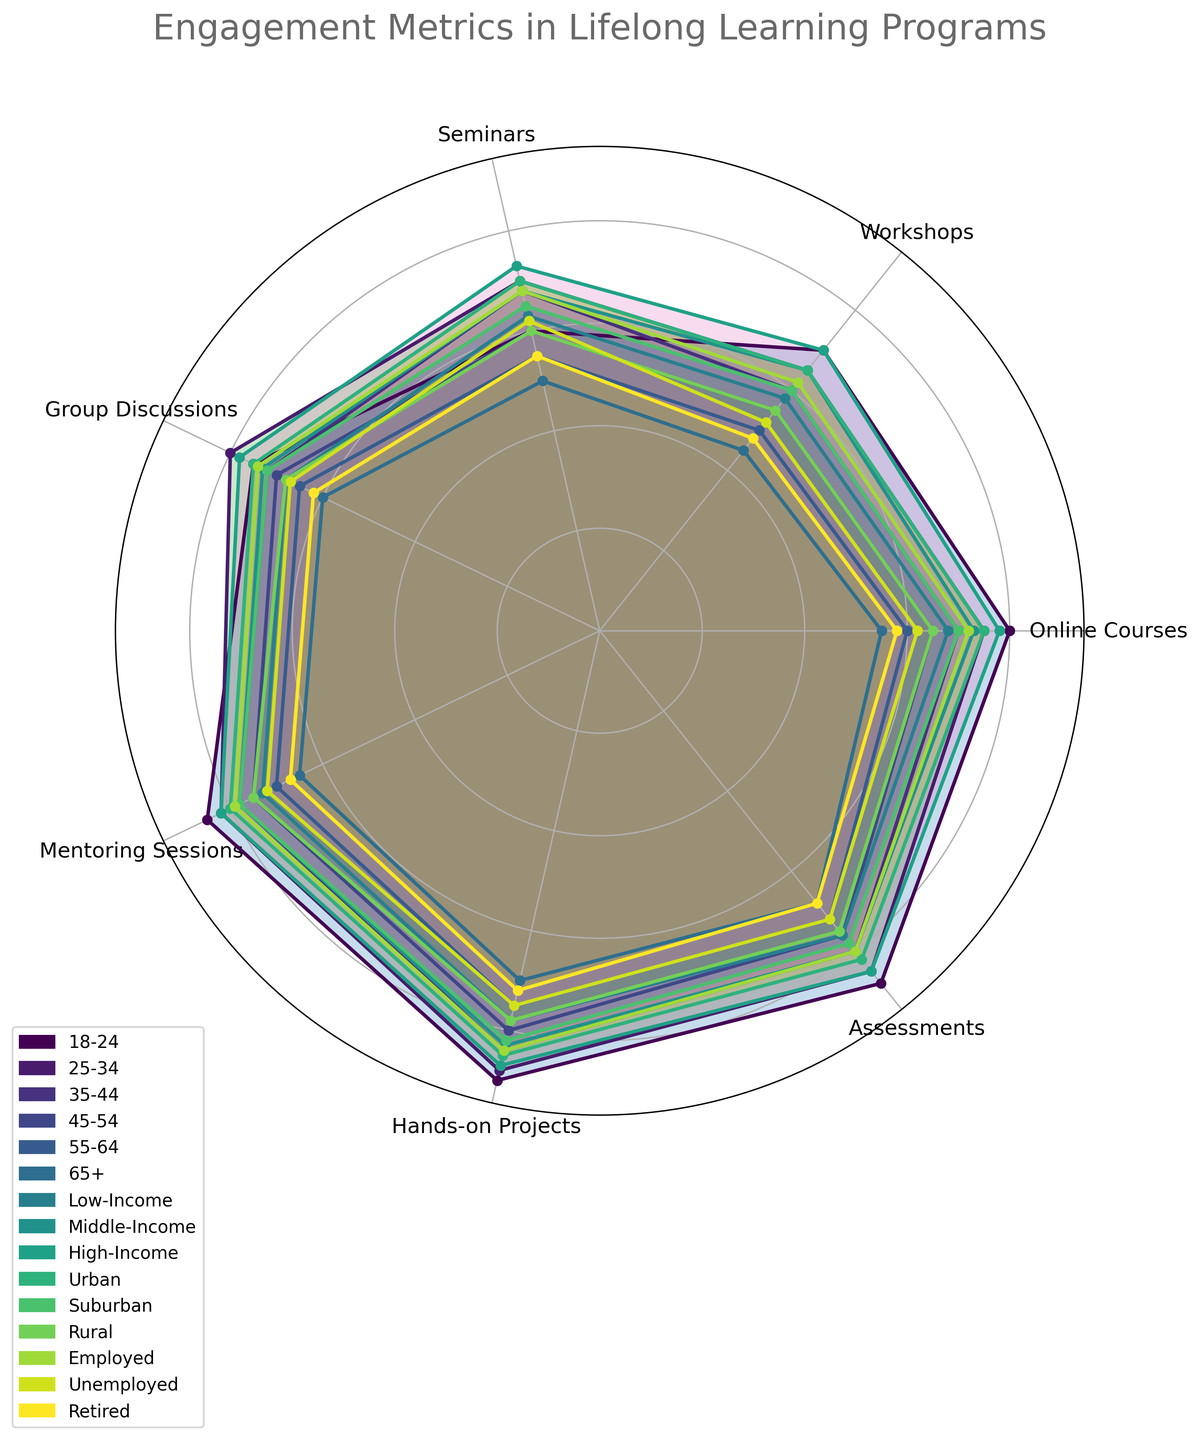What's the highest engagement metric for the 18-24 demographic? In the radar chart, locate the 18-24 demographic line and observe the metric that reaches the highest point. The highest metric for the 18-24 demographic is 90 for Hands-on Projects.
Answer: Hands-on Projects Which demographic has the lowest engagement in Online Courses? Trace the Online Courses axis on the radar chart and identify which demographic has the lowest point on this axis. The lowest engagement in Online Courses is for Retired individuals, with a score of 58.
Answer: Retired Compare the engagement in Workshops between the Low-Income and High-Income demographics. Which one is higher? On the radar chart, locate the lines for Low-Income and High-Income demographics and examine the points on the Workshops axis. The High-Income demographic has a higher engagement in Workshops with a score of 70 compared to 58 for Low-Income.
Answer: High-Income What is the average engagement score for the 45-54 demographic across all metrics? Sum the engagement scores for all metrics in the 45-54 demographic and divide by the number of metrics (7). The sum is 65 + 55 + 60 + 70 + 75 + 80 + 76 = 481. The average is 481 / 7 = 68.71.
Answer: 68.71 Which demographic has a higher average engagement, Suburban or Rural? Calculate the average engagement for both Suburban and Rural demographics. For Suburban, the sum is 70 + 60 + 65 + 72 + 78 + 82 + 78 = 505, and the average is 505 / 7 = 72.14. For Rural, the sum is 65 + 55 + 60 + 68 + 75 + 78 + 75 = 476, and the average is 476 / 7 = 68. Therefore, Suburban has a higher average engagement.
Answer: Suburban Compare the engagement in Group Discussions between the Urban and Employed demographics. Which demographic shows higher engagement? Examine the radar chart and compare the points for Urban and Employed demographics on the Group Discussions axis. Both Urban and Employed have the same engagement score in Group Discussions, which is 75.
Answer: Equal What's the median engagement score for the 35-44 demographic? List the scores for the 35-44 demographic: 70, 60, 68, 72, 78, 84, 80. The median is the middle value when ordered: 60, 68, 70, 72, 78, 80, 84. The median value is 72.
Answer: 72 How does the engagement in Hands-on Projects differ between the 18-24 and 65+ demographics? Locate the points for Hands-on Projects for the 18-24 and 65+ demographics on the radar chart. The score for 18-24 is 90, and for 65+ is 70. The difference is 90 - 70 = 20.
Answer: 20 What is the range of engagement in Assessments for all demographics? Find the highest and lowest engagement scores for Assessments across all demographics. The highest score is 88 (18-24 demographic) and the lowest is 68 (65+ and Retired demographics). The range is 88 - 68 = 20.
Answer: 20 Which demographic has the highest engagement in Mentoring Sessions? Identify the demographic with the highest point on the Mentoring Sessions axis. The highest engagement for Mentoring Sessions is for the 18-24 demographic with a score of 85.
Answer: 18-24 